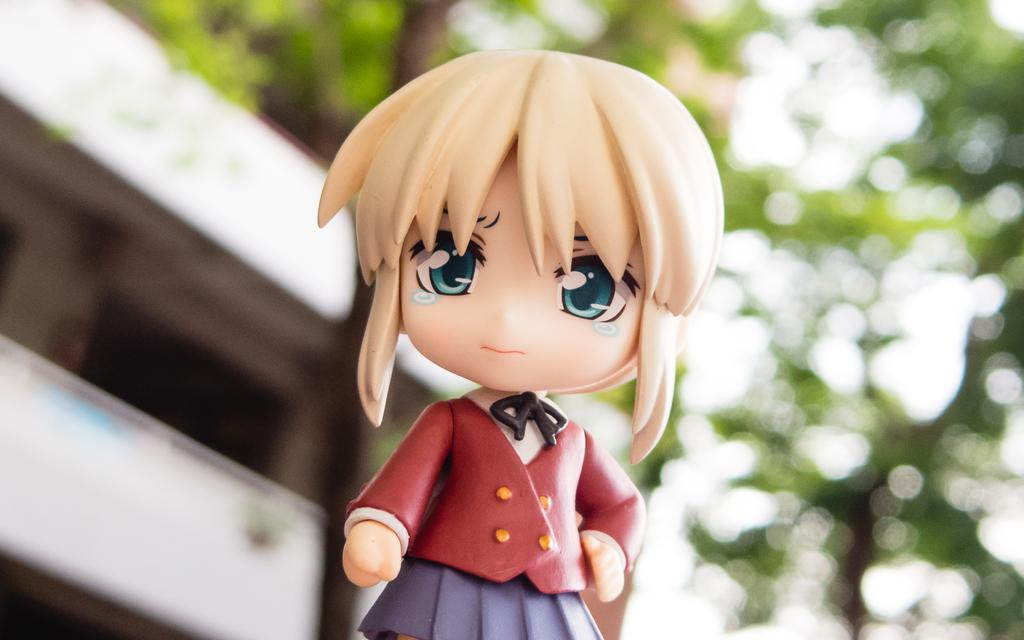What is the main subject of the image? There is a toy in the shape of a girl in the image. Can you describe the background of the image? The background of the image is blurred. How many boats can be seen in the image? There are no boats present in the image. What type of railway is visible in the image? There is no railway present in the image. 